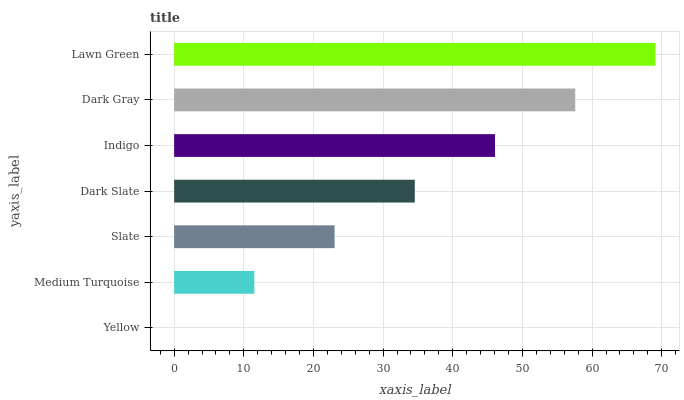Is Yellow the minimum?
Answer yes or no. Yes. Is Lawn Green the maximum?
Answer yes or no. Yes. Is Medium Turquoise the minimum?
Answer yes or no. No. Is Medium Turquoise the maximum?
Answer yes or no. No. Is Medium Turquoise greater than Yellow?
Answer yes or no. Yes. Is Yellow less than Medium Turquoise?
Answer yes or no. Yes. Is Yellow greater than Medium Turquoise?
Answer yes or no. No. Is Medium Turquoise less than Yellow?
Answer yes or no. No. Is Dark Slate the high median?
Answer yes or no. Yes. Is Dark Slate the low median?
Answer yes or no. Yes. Is Yellow the high median?
Answer yes or no. No. Is Dark Gray the low median?
Answer yes or no. No. 